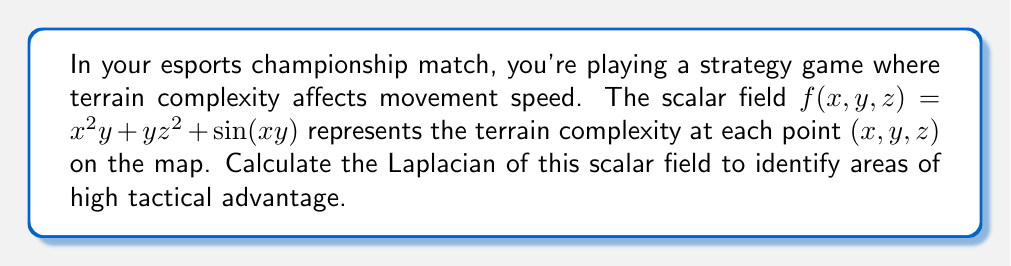Can you solve this math problem? To solve this problem, we need to follow these steps:

1) The Laplacian of a scalar field $f(x,y,z)$ in 3D is defined as:

   $$\nabla^2f = \frac{\partial^2f}{\partial x^2} + \frac{\partial^2f}{\partial y^2} + \frac{\partial^2f}{\partial z^2}$$

2) Let's calculate each second partial derivative:

   a) $\frac{\partial^2f}{\partial x^2}$:
      First, $\frac{\partial f}{\partial x} = 2xy + y\cos(xy)$
      Then, $\frac{\partial^2f}{\partial x^2} = 2y - y^2\sin(xy)$

   b) $\frac{\partial^2f}{\partial y^2}$:
      First, $\frac{\partial f}{\partial y} = x^2 + z^2 + x\cos(xy)$
      Then, $\frac{\partial^2f}{\partial y^2} = -x^2\sin(xy)$

   c) $\frac{\partial^2f}{\partial z^2}$:
      First, $\frac{\partial f}{\partial z} = 2yz$
      Then, $\frac{\partial^2f}{\partial z^2} = 2y$

3) Now, we sum these three second partial derivatives:

   $$\nabla^2f = (2y - y^2\sin(xy)) + (-x^2\sin(xy)) + 2y$$

4) Simplifying:

   $$\nabla^2f = 4y - (x^2 + y^2)\sin(xy)$$

This is the Laplacian of the scalar field representing terrain complexity.
Answer: $4y - (x^2 + y^2)\sin(xy)$ 